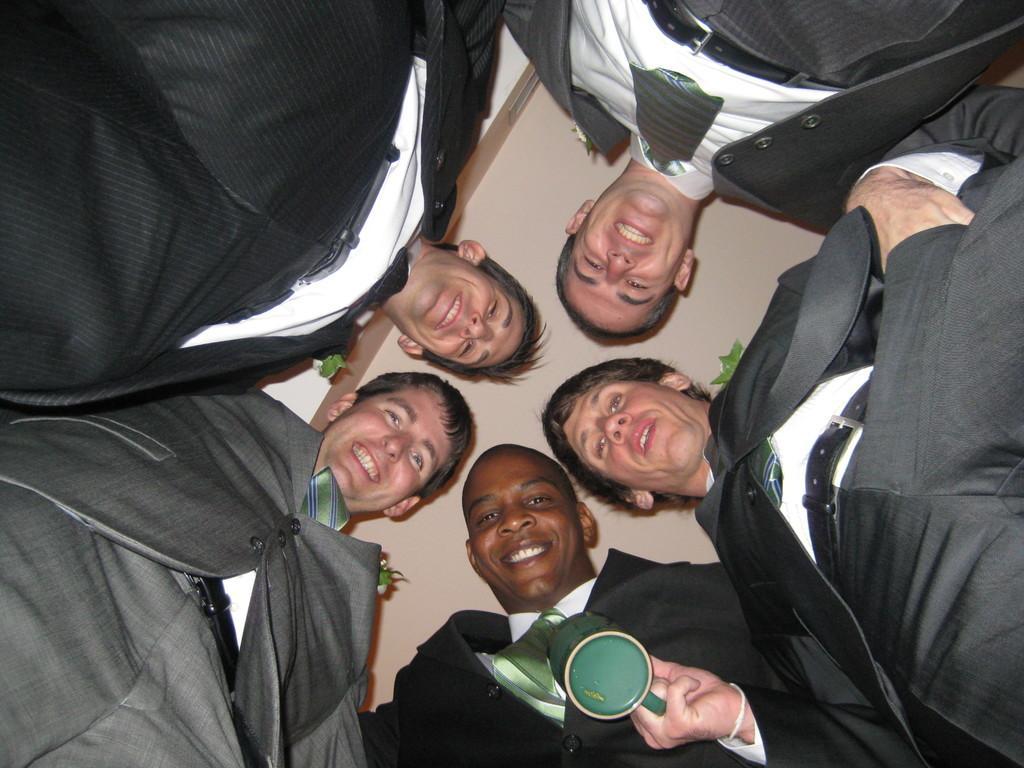Please provide a concise description of this image. The picture consists of group of men wearing suits. In the middle there is a cup. At the top it is ceiling. 